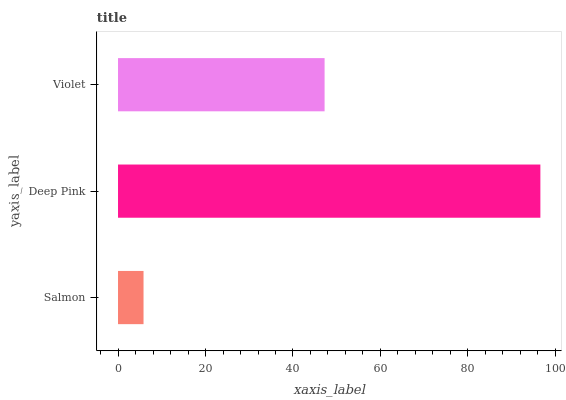Is Salmon the minimum?
Answer yes or no. Yes. Is Deep Pink the maximum?
Answer yes or no. Yes. Is Violet the minimum?
Answer yes or no. No. Is Violet the maximum?
Answer yes or no. No. Is Deep Pink greater than Violet?
Answer yes or no. Yes. Is Violet less than Deep Pink?
Answer yes or no. Yes. Is Violet greater than Deep Pink?
Answer yes or no. No. Is Deep Pink less than Violet?
Answer yes or no. No. Is Violet the high median?
Answer yes or no. Yes. Is Violet the low median?
Answer yes or no. Yes. Is Salmon the high median?
Answer yes or no. No. Is Deep Pink the low median?
Answer yes or no. No. 